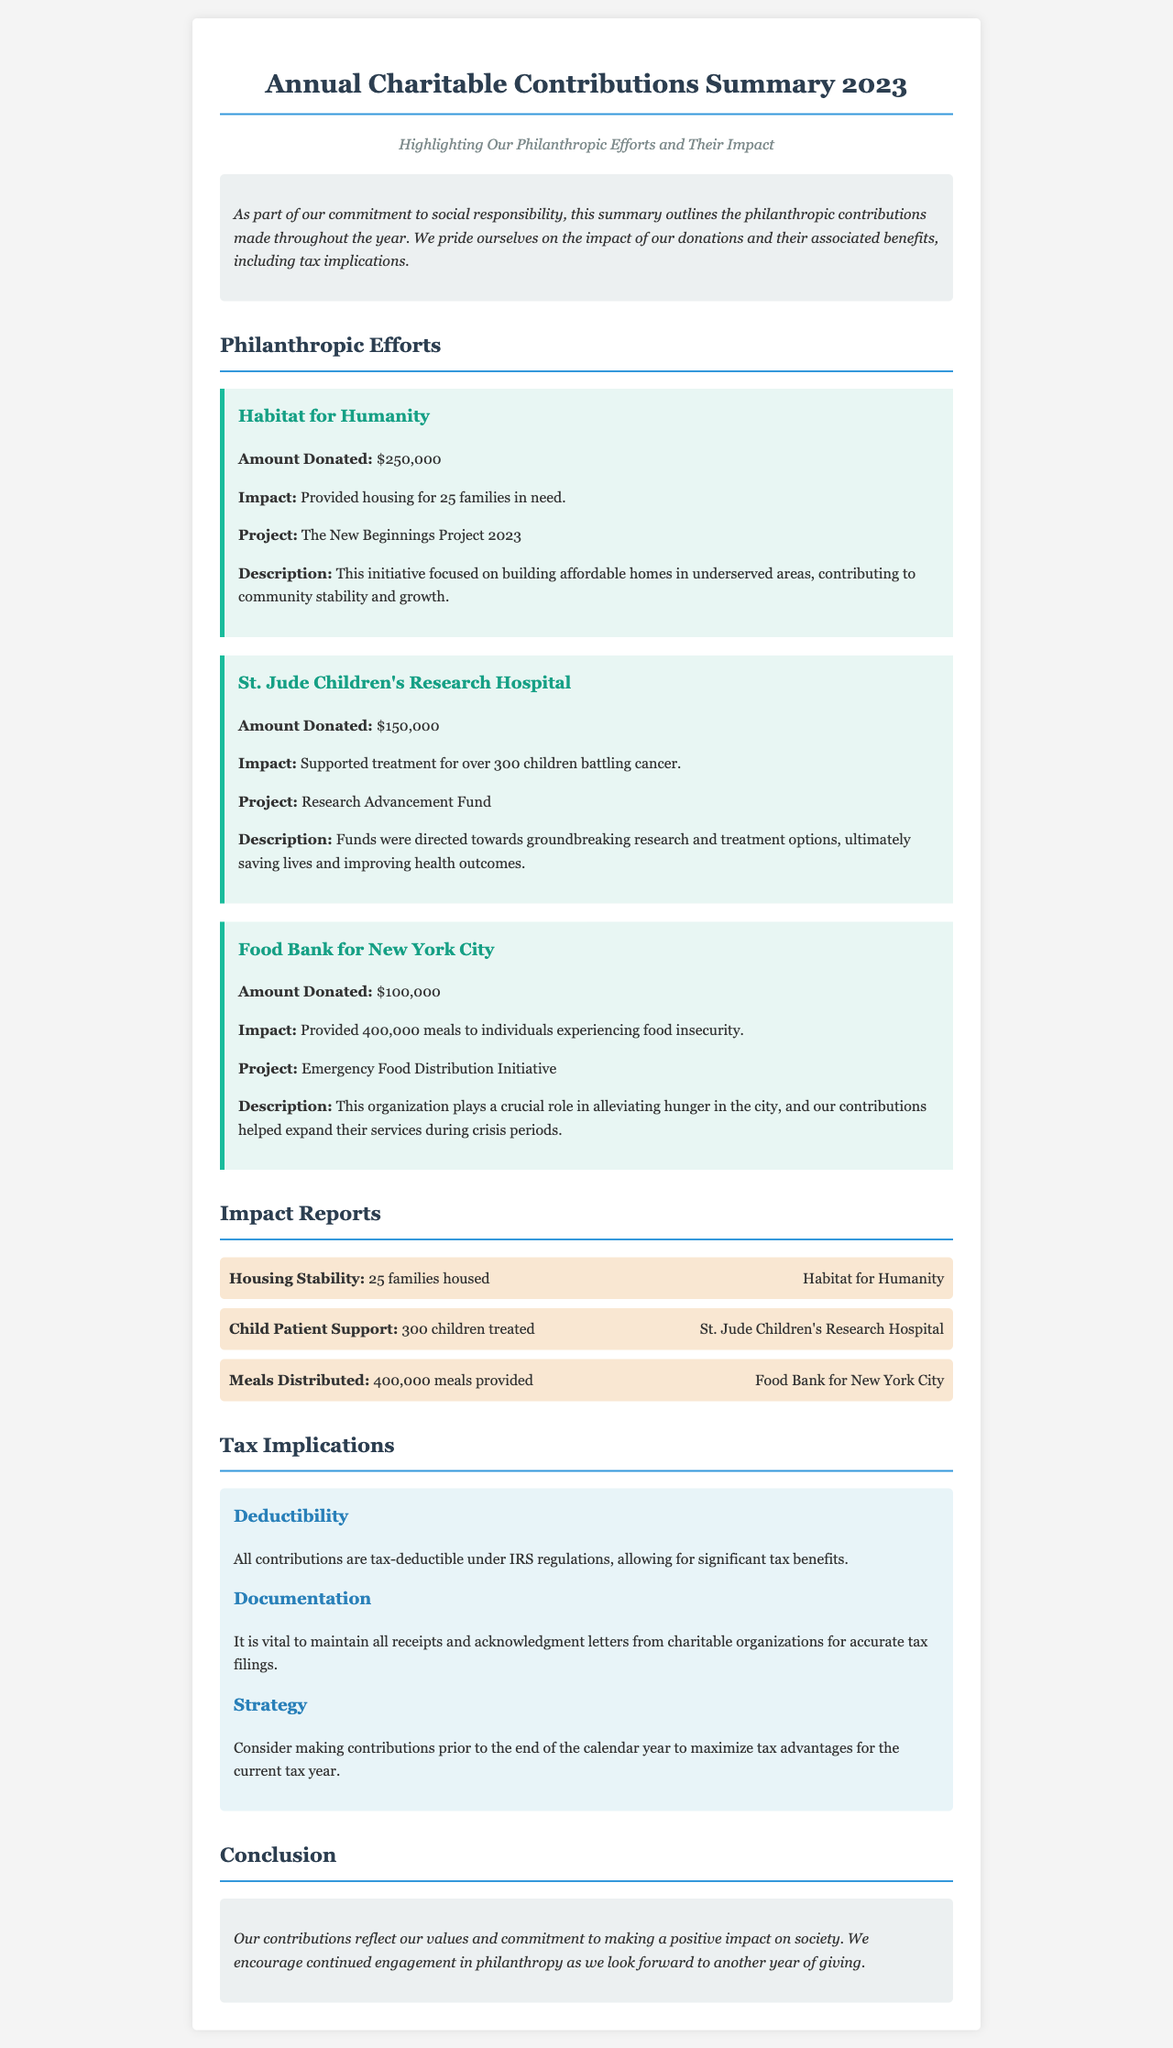What was the total amount donated to Habitat for Humanity? The total amount donated to Habitat for Humanity is explicitly stated in the document as $250,000.
Answer: $250,000 How many meals were provided by the Food Bank for New York City? The document specifies that the Food Bank for New York City provided 400,000 meals to individuals.
Answer: 400,000 meals What description is given for the New Beginnings Project 2023? The description provided in the document states that it focused on building affordable homes in underserved areas, contributing to community stability and growth.
Answer: Building affordable homes in underserved areas How many children were treated by St. Jude Children's Research Hospital? The summary mentions that over 300 children battling cancer were supported with treatment.
Answer: 300 children What is the tax-deductibility status of all contributions? The document outlines that all contributions are tax-deductible under IRS regulations, indicating their significant tax benefits.
Answer: Tax-deductible What should be maintained for accurate tax filings? The document advises that it is vital to maintain all receipts and acknowledgment letters from charitable organizations for accurate tax filings.
Answer: Receipts and acknowledgment letters What is the overarching theme of the newsletter? The document conveys a commitment to social responsibility and highlights the impact of philanthropic contributions throughout the year.
Answer: Commitment to social responsibility Which organization received the smallest donation? According to the document, the organization that received the smallest donation is the Food Bank for New York City with $100,000.
Answer: Food Bank for New York City What initiative was supported by the contributions to St. Jude Children's Research Hospital? The document states that the funds were directed towards the Research Advancement Fund at St. Jude Children's Research Hospital.
Answer: Research Advancement Fund 